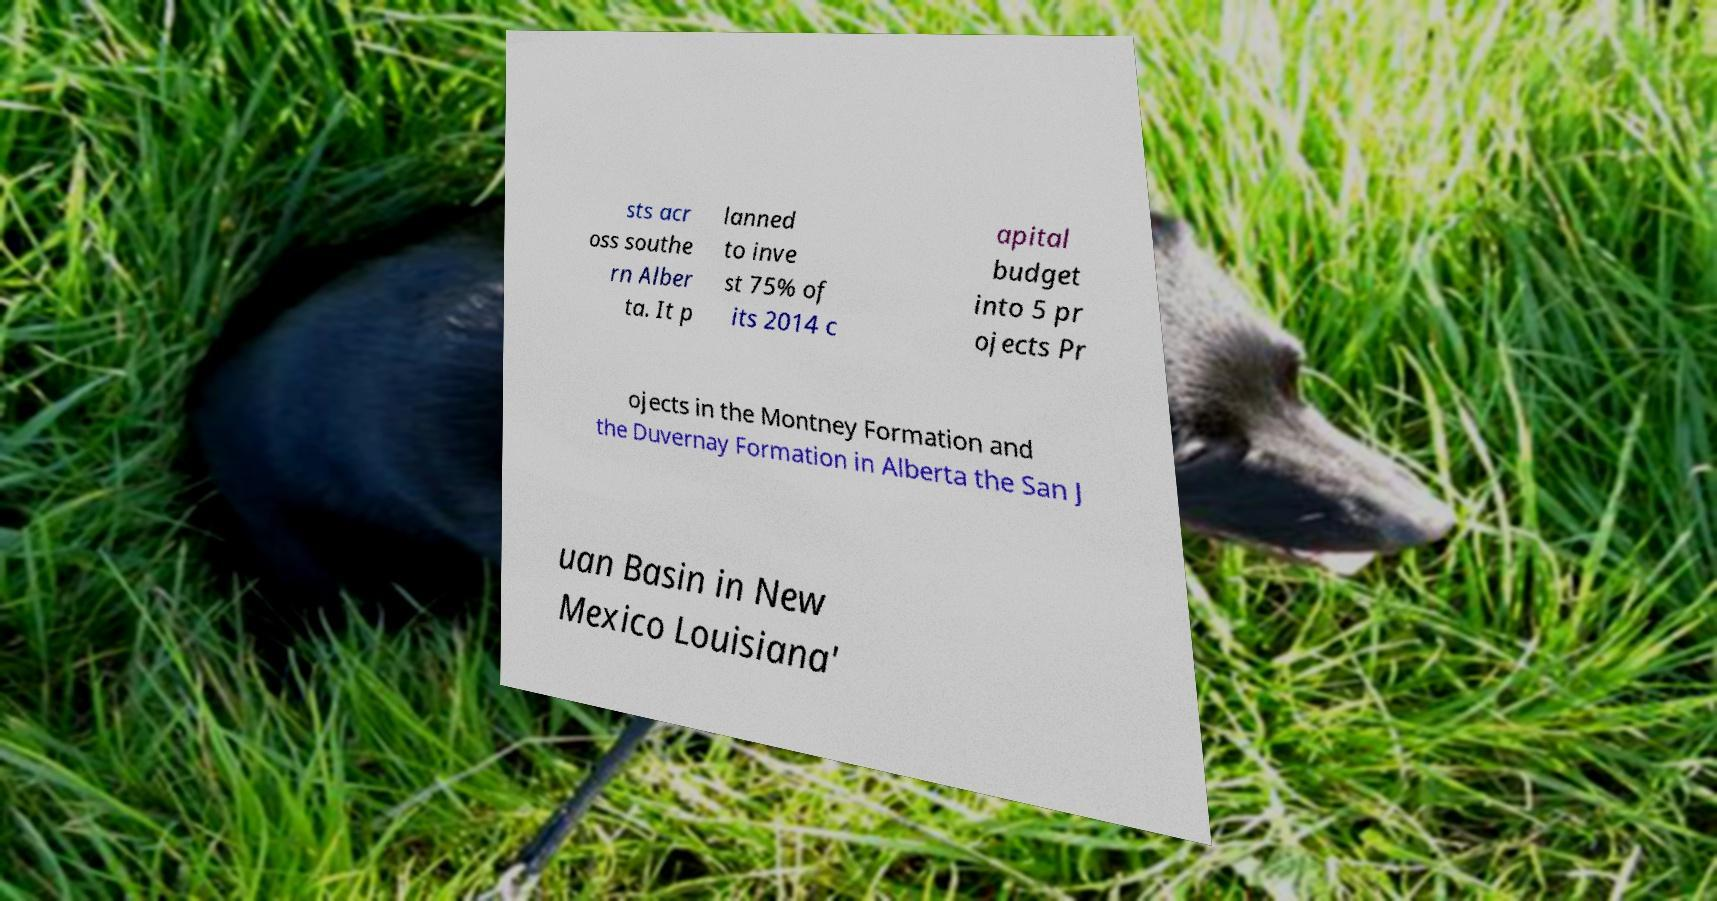Could you assist in decoding the text presented in this image and type it out clearly? sts acr oss southe rn Alber ta. It p lanned to inve st 75% of its 2014 c apital budget into 5 pr ojects Pr ojects in the Montney Formation and the Duvernay Formation in Alberta the San J uan Basin in New Mexico Louisiana' 